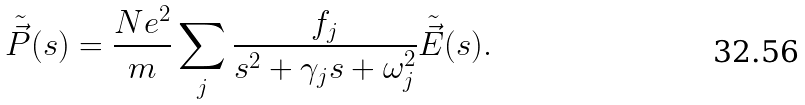Convert formula to latex. <formula><loc_0><loc_0><loc_500><loc_500>\tilde { \vec { P } } ( s ) = \frac { N e ^ { 2 } } { m } \sum _ { j } \frac { f _ { j } } { s ^ { 2 } + \gamma _ { j } s + \omega _ { j } ^ { 2 } } \tilde { \vec { E } } ( s ) .</formula> 